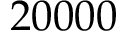<formula> <loc_0><loc_0><loc_500><loc_500>2 0 0 0 0</formula> 